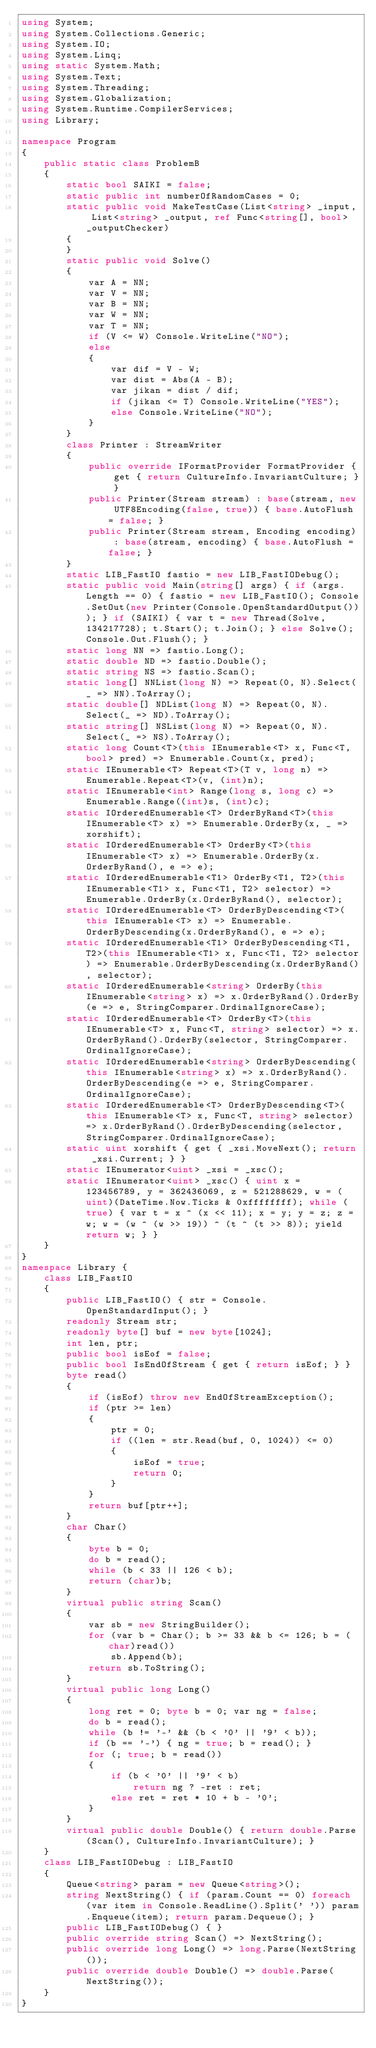<code> <loc_0><loc_0><loc_500><loc_500><_C#_>using System;
using System.Collections.Generic;
using System.IO;
using System.Linq;
using static System.Math;
using System.Text;
using System.Threading;
using System.Globalization;
using System.Runtime.CompilerServices;
using Library;

namespace Program
{
    public static class ProblemB
    {
        static bool SAIKI = false;
        static public int numberOfRandomCases = 0;
        static public void MakeTestCase(List<string> _input, List<string> _output, ref Func<string[], bool> _outputChecker)
        {
        }
        static public void Solve()
        {
            var A = NN;
            var V = NN;
            var B = NN;
            var W = NN;
            var T = NN;
            if (V <= W) Console.WriteLine("NO");
            else
            {
                var dif = V - W;
                var dist = Abs(A - B);
                var jikan = dist / dif;
                if (jikan <= T) Console.WriteLine("YES");
                else Console.WriteLine("NO");
            }
        }
        class Printer : StreamWriter
        {
            public override IFormatProvider FormatProvider { get { return CultureInfo.InvariantCulture; } }
            public Printer(Stream stream) : base(stream, new UTF8Encoding(false, true)) { base.AutoFlush = false; }
            public Printer(Stream stream, Encoding encoding) : base(stream, encoding) { base.AutoFlush = false; }
        }
        static LIB_FastIO fastio = new LIB_FastIODebug();
        static public void Main(string[] args) { if (args.Length == 0) { fastio = new LIB_FastIO(); Console.SetOut(new Printer(Console.OpenStandardOutput())); } if (SAIKI) { var t = new Thread(Solve, 134217728); t.Start(); t.Join(); } else Solve(); Console.Out.Flush(); }
        static long NN => fastio.Long();
        static double ND => fastio.Double();
        static string NS => fastio.Scan();
        static long[] NNList(long N) => Repeat(0, N).Select(_ => NN).ToArray();
        static double[] NDList(long N) => Repeat(0, N).Select(_ => ND).ToArray();
        static string[] NSList(long N) => Repeat(0, N).Select(_ => NS).ToArray();
        static long Count<T>(this IEnumerable<T> x, Func<T, bool> pred) => Enumerable.Count(x, pred);
        static IEnumerable<T> Repeat<T>(T v, long n) => Enumerable.Repeat<T>(v, (int)n);
        static IEnumerable<int> Range(long s, long c) => Enumerable.Range((int)s, (int)c);
        static IOrderedEnumerable<T> OrderByRand<T>(this IEnumerable<T> x) => Enumerable.OrderBy(x, _ => xorshift);
        static IOrderedEnumerable<T> OrderBy<T>(this IEnumerable<T> x) => Enumerable.OrderBy(x.OrderByRand(), e => e);
        static IOrderedEnumerable<T1> OrderBy<T1, T2>(this IEnumerable<T1> x, Func<T1, T2> selector) => Enumerable.OrderBy(x.OrderByRand(), selector);
        static IOrderedEnumerable<T> OrderByDescending<T>(this IEnumerable<T> x) => Enumerable.OrderByDescending(x.OrderByRand(), e => e);
        static IOrderedEnumerable<T1> OrderByDescending<T1, T2>(this IEnumerable<T1> x, Func<T1, T2> selector) => Enumerable.OrderByDescending(x.OrderByRand(), selector);
        static IOrderedEnumerable<string> OrderBy(this IEnumerable<string> x) => x.OrderByRand().OrderBy(e => e, StringComparer.OrdinalIgnoreCase);
        static IOrderedEnumerable<T> OrderBy<T>(this IEnumerable<T> x, Func<T, string> selector) => x.OrderByRand().OrderBy(selector, StringComparer.OrdinalIgnoreCase);
        static IOrderedEnumerable<string> OrderByDescending(this IEnumerable<string> x) => x.OrderByRand().OrderByDescending(e => e, StringComparer.OrdinalIgnoreCase);
        static IOrderedEnumerable<T> OrderByDescending<T>(this IEnumerable<T> x, Func<T, string> selector) => x.OrderByRand().OrderByDescending(selector, StringComparer.OrdinalIgnoreCase);
        static uint xorshift { get { _xsi.MoveNext(); return _xsi.Current; } }
        static IEnumerator<uint> _xsi = _xsc();
        static IEnumerator<uint> _xsc() { uint x = 123456789, y = 362436069, z = 521288629, w = (uint)(DateTime.Now.Ticks & 0xffffffff); while (true) { var t = x ^ (x << 11); x = y; y = z; z = w; w = (w ^ (w >> 19)) ^ (t ^ (t >> 8)); yield return w; } }
    }
}
namespace Library {
    class LIB_FastIO
    {
        public LIB_FastIO() { str = Console.OpenStandardInput(); }
        readonly Stream str;
        readonly byte[] buf = new byte[1024];
        int len, ptr;
        public bool isEof = false;
        public bool IsEndOfStream { get { return isEof; } }
        byte read()
        {
            if (isEof) throw new EndOfStreamException();
            if (ptr >= len)
            {
                ptr = 0;
                if ((len = str.Read(buf, 0, 1024)) <= 0)
                {
                    isEof = true;
                    return 0;
                }
            }
            return buf[ptr++];
        }
        char Char()
        {
            byte b = 0;
            do b = read();
            while (b < 33 || 126 < b);
            return (char)b;
        }
        virtual public string Scan()
        {
            var sb = new StringBuilder();
            for (var b = Char(); b >= 33 && b <= 126; b = (char)read())
                sb.Append(b);
            return sb.ToString();
        }
        virtual public long Long()
        {
            long ret = 0; byte b = 0; var ng = false;
            do b = read();
            while (b != '-' && (b < '0' || '9' < b));
            if (b == '-') { ng = true; b = read(); }
            for (; true; b = read())
            {
                if (b < '0' || '9' < b)
                    return ng ? -ret : ret;
                else ret = ret * 10 + b - '0';
            }
        }
        virtual public double Double() { return double.Parse(Scan(), CultureInfo.InvariantCulture); }
    }
    class LIB_FastIODebug : LIB_FastIO
    {
        Queue<string> param = new Queue<string>();
        string NextString() { if (param.Count == 0) foreach (var item in Console.ReadLine().Split(' ')) param.Enqueue(item); return param.Dequeue(); }
        public LIB_FastIODebug() { }
        public override string Scan() => NextString();
        public override long Long() => long.Parse(NextString());
        public override double Double() => double.Parse(NextString());
    }
}
</code> 